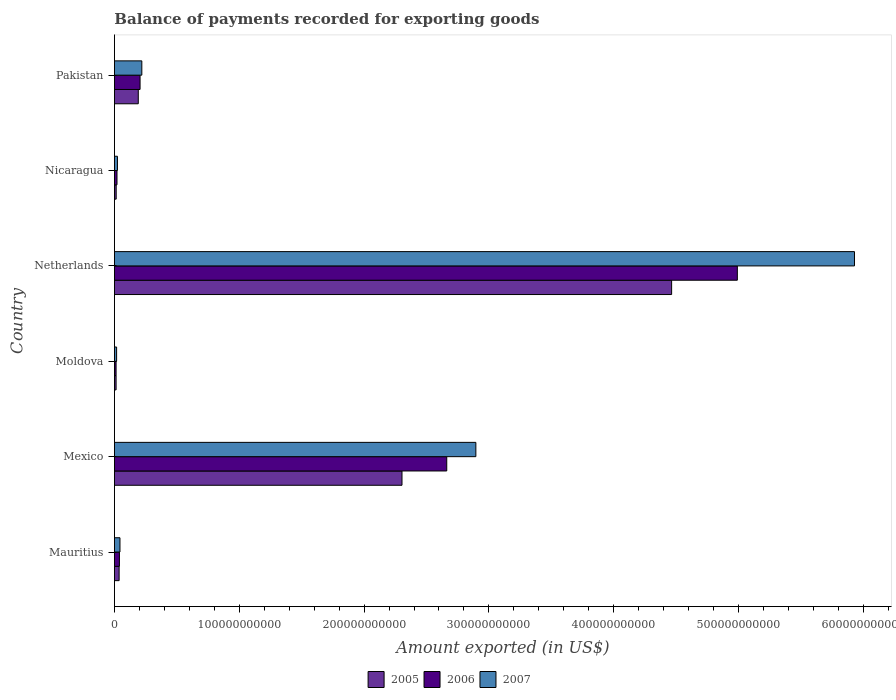How many groups of bars are there?
Your answer should be compact. 6. How many bars are there on the 4th tick from the top?
Make the answer very short. 3. What is the label of the 4th group of bars from the top?
Provide a succinct answer. Moldova. What is the amount exported in 2007 in Mexico?
Provide a succinct answer. 2.90e+11. Across all countries, what is the maximum amount exported in 2005?
Your response must be concise. 4.46e+11. Across all countries, what is the minimum amount exported in 2005?
Keep it short and to the point. 1.33e+09. In which country was the amount exported in 2006 minimum?
Offer a very short reply. Moldova. What is the total amount exported in 2005 in the graph?
Offer a very short reply. 7.02e+11. What is the difference between the amount exported in 2005 in Mexico and that in Nicaragua?
Make the answer very short. 2.29e+11. What is the difference between the amount exported in 2007 in Netherlands and the amount exported in 2005 in Nicaragua?
Provide a short and direct response. 5.91e+11. What is the average amount exported in 2006 per country?
Offer a terse response. 1.32e+11. What is the difference between the amount exported in 2005 and amount exported in 2007 in Mauritius?
Give a very brief answer. -6.87e+08. In how many countries, is the amount exported in 2005 greater than 100000000000 US$?
Offer a very short reply. 2. What is the ratio of the amount exported in 2007 in Mauritius to that in Moldova?
Your answer should be compact. 2.55. What is the difference between the highest and the second highest amount exported in 2007?
Keep it short and to the point. 3.03e+11. What is the difference between the highest and the lowest amount exported in 2007?
Your answer should be very brief. 5.91e+11. In how many countries, is the amount exported in 2006 greater than the average amount exported in 2006 taken over all countries?
Keep it short and to the point. 2. Is the sum of the amount exported in 2006 in Moldova and Pakistan greater than the maximum amount exported in 2005 across all countries?
Your response must be concise. No. Are all the bars in the graph horizontal?
Your answer should be compact. Yes. What is the difference between two consecutive major ticks on the X-axis?
Your response must be concise. 1.00e+11. Does the graph contain grids?
Offer a terse response. No. How many legend labels are there?
Keep it short and to the point. 3. What is the title of the graph?
Give a very brief answer. Balance of payments recorded for exporting goods. What is the label or title of the X-axis?
Offer a very short reply. Amount exported (in US$). What is the label or title of the Y-axis?
Offer a very short reply. Country. What is the Amount exported (in US$) of 2005 in Mauritius?
Make the answer very short. 3.76e+09. What is the Amount exported (in US$) in 2006 in Mauritius?
Provide a short and direct response. 4.00e+09. What is the Amount exported (in US$) of 2007 in Mauritius?
Your response must be concise. 4.44e+09. What is the Amount exported (in US$) of 2005 in Mexico?
Keep it short and to the point. 2.30e+11. What is the Amount exported (in US$) of 2006 in Mexico?
Your answer should be very brief. 2.66e+11. What is the Amount exported (in US$) of 2007 in Mexico?
Give a very brief answer. 2.90e+11. What is the Amount exported (in US$) in 2005 in Moldova?
Ensure brevity in your answer.  1.33e+09. What is the Amount exported (in US$) of 2006 in Moldova?
Offer a very short reply. 1.32e+09. What is the Amount exported (in US$) in 2007 in Moldova?
Your response must be concise. 1.75e+09. What is the Amount exported (in US$) of 2005 in Netherlands?
Ensure brevity in your answer.  4.46e+11. What is the Amount exported (in US$) of 2006 in Netherlands?
Your response must be concise. 4.99e+11. What is the Amount exported (in US$) of 2007 in Netherlands?
Your answer should be compact. 5.93e+11. What is the Amount exported (in US$) in 2005 in Nicaragua?
Ensure brevity in your answer.  1.41e+09. What is the Amount exported (in US$) of 2006 in Nicaragua?
Provide a short and direct response. 2.05e+09. What is the Amount exported (in US$) in 2007 in Nicaragua?
Ensure brevity in your answer.  2.42e+09. What is the Amount exported (in US$) in 2005 in Pakistan?
Give a very brief answer. 1.91e+1. What is the Amount exported (in US$) of 2006 in Pakistan?
Offer a terse response. 2.05e+1. What is the Amount exported (in US$) in 2007 in Pakistan?
Your answer should be very brief. 2.19e+1. Across all countries, what is the maximum Amount exported (in US$) in 2005?
Provide a succinct answer. 4.46e+11. Across all countries, what is the maximum Amount exported (in US$) of 2006?
Give a very brief answer. 4.99e+11. Across all countries, what is the maximum Amount exported (in US$) of 2007?
Provide a short and direct response. 5.93e+11. Across all countries, what is the minimum Amount exported (in US$) of 2005?
Offer a terse response. 1.33e+09. Across all countries, what is the minimum Amount exported (in US$) in 2006?
Provide a short and direct response. 1.32e+09. Across all countries, what is the minimum Amount exported (in US$) of 2007?
Offer a very short reply. 1.75e+09. What is the total Amount exported (in US$) of 2005 in the graph?
Keep it short and to the point. 7.02e+11. What is the total Amount exported (in US$) of 2006 in the graph?
Give a very brief answer. 7.93e+11. What is the total Amount exported (in US$) of 2007 in the graph?
Provide a short and direct response. 9.13e+11. What is the difference between the Amount exported (in US$) in 2005 in Mauritius and that in Mexico?
Your response must be concise. -2.27e+11. What is the difference between the Amount exported (in US$) of 2006 in Mauritius and that in Mexico?
Your response must be concise. -2.62e+11. What is the difference between the Amount exported (in US$) in 2007 in Mauritius and that in Mexico?
Provide a short and direct response. -2.85e+11. What is the difference between the Amount exported (in US$) of 2005 in Mauritius and that in Moldova?
Offer a terse response. 2.42e+09. What is the difference between the Amount exported (in US$) of 2006 in Mauritius and that in Moldova?
Your answer should be compact. 2.68e+09. What is the difference between the Amount exported (in US$) in 2007 in Mauritius and that in Moldova?
Offer a terse response. 2.70e+09. What is the difference between the Amount exported (in US$) in 2005 in Mauritius and that in Netherlands?
Your answer should be very brief. -4.43e+11. What is the difference between the Amount exported (in US$) in 2006 in Mauritius and that in Netherlands?
Offer a very short reply. -4.95e+11. What is the difference between the Amount exported (in US$) of 2007 in Mauritius and that in Netherlands?
Give a very brief answer. -5.88e+11. What is the difference between the Amount exported (in US$) of 2005 in Mauritius and that in Nicaragua?
Offer a very short reply. 2.35e+09. What is the difference between the Amount exported (in US$) of 2006 in Mauritius and that in Nicaragua?
Provide a short and direct response. 1.95e+09. What is the difference between the Amount exported (in US$) in 2007 in Mauritius and that in Nicaragua?
Provide a short and direct response. 2.02e+09. What is the difference between the Amount exported (in US$) of 2005 in Mauritius and that in Pakistan?
Provide a short and direct response. -1.53e+1. What is the difference between the Amount exported (in US$) in 2006 in Mauritius and that in Pakistan?
Your answer should be compact. -1.65e+1. What is the difference between the Amount exported (in US$) in 2007 in Mauritius and that in Pakistan?
Provide a succinct answer. -1.75e+1. What is the difference between the Amount exported (in US$) in 2005 in Mexico and that in Moldova?
Make the answer very short. 2.29e+11. What is the difference between the Amount exported (in US$) in 2006 in Mexico and that in Moldova?
Provide a short and direct response. 2.65e+11. What is the difference between the Amount exported (in US$) of 2007 in Mexico and that in Moldova?
Offer a terse response. 2.88e+11. What is the difference between the Amount exported (in US$) of 2005 in Mexico and that in Netherlands?
Offer a terse response. -2.16e+11. What is the difference between the Amount exported (in US$) in 2006 in Mexico and that in Netherlands?
Give a very brief answer. -2.33e+11. What is the difference between the Amount exported (in US$) in 2007 in Mexico and that in Netherlands?
Give a very brief answer. -3.03e+11. What is the difference between the Amount exported (in US$) in 2005 in Mexico and that in Nicaragua?
Provide a short and direct response. 2.29e+11. What is the difference between the Amount exported (in US$) of 2006 in Mexico and that in Nicaragua?
Ensure brevity in your answer.  2.64e+11. What is the difference between the Amount exported (in US$) in 2007 in Mexico and that in Nicaragua?
Provide a succinct answer. 2.87e+11. What is the difference between the Amount exported (in US$) of 2005 in Mexico and that in Pakistan?
Your answer should be compact. 2.11e+11. What is the difference between the Amount exported (in US$) of 2006 in Mexico and that in Pakistan?
Your answer should be very brief. 2.46e+11. What is the difference between the Amount exported (in US$) of 2007 in Mexico and that in Pakistan?
Your answer should be compact. 2.68e+11. What is the difference between the Amount exported (in US$) of 2005 in Moldova and that in Netherlands?
Provide a short and direct response. -4.45e+11. What is the difference between the Amount exported (in US$) in 2006 in Moldova and that in Netherlands?
Keep it short and to the point. -4.98e+11. What is the difference between the Amount exported (in US$) in 2007 in Moldova and that in Netherlands?
Keep it short and to the point. -5.91e+11. What is the difference between the Amount exported (in US$) in 2005 in Moldova and that in Nicaragua?
Your answer should be very brief. -7.89e+07. What is the difference between the Amount exported (in US$) in 2006 in Moldova and that in Nicaragua?
Offer a terse response. -7.32e+08. What is the difference between the Amount exported (in US$) in 2007 in Moldova and that in Nicaragua?
Provide a succinct answer. -6.74e+08. What is the difference between the Amount exported (in US$) in 2005 in Moldova and that in Pakistan?
Provide a short and direct response. -1.78e+1. What is the difference between the Amount exported (in US$) in 2006 in Moldova and that in Pakistan?
Ensure brevity in your answer.  -1.92e+1. What is the difference between the Amount exported (in US$) in 2007 in Moldova and that in Pakistan?
Provide a short and direct response. -2.02e+1. What is the difference between the Amount exported (in US$) of 2005 in Netherlands and that in Nicaragua?
Your answer should be very brief. 4.45e+11. What is the difference between the Amount exported (in US$) of 2006 in Netherlands and that in Nicaragua?
Provide a succinct answer. 4.97e+11. What is the difference between the Amount exported (in US$) of 2007 in Netherlands and that in Nicaragua?
Offer a very short reply. 5.90e+11. What is the difference between the Amount exported (in US$) of 2005 in Netherlands and that in Pakistan?
Your answer should be very brief. 4.27e+11. What is the difference between the Amount exported (in US$) in 2006 in Netherlands and that in Pakistan?
Your answer should be very brief. 4.78e+11. What is the difference between the Amount exported (in US$) in 2007 in Netherlands and that in Pakistan?
Offer a very short reply. 5.71e+11. What is the difference between the Amount exported (in US$) of 2005 in Nicaragua and that in Pakistan?
Your answer should be compact. -1.77e+1. What is the difference between the Amount exported (in US$) of 2006 in Nicaragua and that in Pakistan?
Make the answer very short. -1.85e+1. What is the difference between the Amount exported (in US$) in 2007 in Nicaragua and that in Pakistan?
Ensure brevity in your answer.  -1.95e+1. What is the difference between the Amount exported (in US$) of 2005 in Mauritius and the Amount exported (in US$) of 2006 in Mexico?
Your answer should be compact. -2.62e+11. What is the difference between the Amount exported (in US$) of 2005 in Mauritius and the Amount exported (in US$) of 2007 in Mexico?
Provide a succinct answer. -2.86e+11. What is the difference between the Amount exported (in US$) of 2006 in Mauritius and the Amount exported (in US$) of 2007 in Mexico?
Make the answer very short. -2.86e+11. What is the difference between the Amount exported (in US$) in 2005 in Mauritius and the Amount exported (in US$) in 2006 in Moldova?
Offer a terse response. 2.43e+09. What is the difference between the Amount exported (in US$) of 2005 in Mauritius and the Amount exported (in US$) of 2007 in Moldova?
Keep it short and to the point. 2.01e+09. What is the difference between the Amount exported (in US$) in 2006 in Mauritius and the Amount exported (in US$) in 2007 in Moldova?
Offer a terse response. 2.25e+09. What is the difference between the Amount exported (in US$) of 2005 in Mauritius and the Amount exported (in US$) of 2006 in Netherlands?
Provide a short and direct response. -4.95e+11. What is the difference between the Amount exported (in US$) in 2005 in Mauritius and the Amount exported (in US$) in 2007 in Netherlands?
Keep it short and to the point. -5.89e+11. What is the difference between the Amount exported (in US$) in 2006 in Mauritius and the Amount exported (in US$) in 2007 in Netherlands?
Ensure brevity in your answer.  -5.89e+11. What is the difference between the Amount exported (in US$) in 2005 in Mauritius and the Amount exported (in US$) in 2006 in Nicaragua?
Ensure brevity in your answer.  1.70e+09. What is the difference between the Amount exported (in US$) of 2005 in Mauritius and the Amount exported (in US$) of 2007 in Nicaragua?
Give a very brief answer. 1.34e+09. What is the difference between the Amount exported (in US$) of 2006 in Mauritius and the Amount exported (in US$) of 2007 in Nicaragua?
Keep it short and to the point. 1.58e+09. What is the difference between the Amount exported (in US$) in 2005 in Mauritius and the Amount exported (in US$) in 2006 in Pakistan?
Your answer should be compact. -1.68e+1. What is the difference between the Amount exported (in US$) in 2005 in Mauritius and the Amount exported (in US$) in 2007 in Pakistan?
Your answer should be very brief. -1.82e+1. What is the difference between the Amount exported (in US$) in 2006 in Mauritius and the Amount exported (in US$) in 2007 in Pakistan?
Your answer should be very brief. -1.79e+1. What is the difference between the Amount exported (in US$) in 2005 in Mexico and the Amount exported (in US$) in 2006 in Moldova?
Your response must be concise. 2.29e+11. What is the difference between the Amount exported (in US$) in 2005 in Mexico and the Amount exported (in US$) in 2007 in Moldova?
Provide a succinct answer. 2.29e+11. What is the difference between the Amount exported (in US$) of 2006 in Mexico and the Amount exported (in US$) of 2007 in Moldova?
Your answer should be compact. 2.64e+11. What is the difference between the Amount exported (in US$) of 2005 in Mexico and the Amount exported (in US$) of 2006 in Netherlands?
Provide a succinct answer. -2.69e+11. What is the difference between the Amount exported (in US$) of 2005 in Mexico and the Amount exported (in US$) of 2007 in Netherlands?
Provide a short and direct response. -3.62e+11. What is the difference between the Amount exported (in US$) in 2006 in Mexico and the Amount exported (in US$) in 2007 in Netherlands?
Your answer should be compact. -3.27e+11. What is the difference between the Amount exported (in US$) in 2005 in Mexico and the Amount exported (in US$) in 2006 in Nicaragua?
Ensure brevity in your answer.  2.28e+11. What is the difference between the Amount exported (in US$) in 2005 in Mexico and the Amount exported (in US$) in 2007 in Nicaragua?
Offer a very short reply. 2.28e+11. What is the difference between the Amount exported (in US$) in 2006 in Mexico and the Amount exported (in US$) in 2007 in Nicaragua?
Keep it short and to the point. 2.64e+11. What is the difference between the Amount exported (in US$) of 2005 in Mexico and the Amount exported (in US$) of 2006 in Pakistan?
Provide a succinct answer. 2.10e+11. What is the difference between the Amount exported (in US$) in 2005 in Mexico and the Amount exported (in US$) in 2007 in Pakistan?
Give a very brief answer. 2.08e+11. What is the difference between the Amount exported (in US$) in 2006 in Mexico and the Amount exported (in US$) in 2007 in Pakistan?
Offer a very short reply. 2.44e+11. What is the difference between the Amount exported (in US$) of 2005 in Moldova and the Amount exported (in US$) of 2006 in Netherlands?
Offer a terse response. -4.98e+11. What is the difference between the Amount exported (in US$) in 2005 in Moldova and the Amount exported (in US$) in 2007 in Netherlands?
Provide a succinct answer. -5.92e+11. What is the difference between the Amount exported (in US$) in 2006 in Moldova and the Amount exported (in US$) in 2007 in Netherlands?
Give a very brief answer. -5.92e+11. What is the difference between the Amount exported (in US$) of 2005 in Moldova and the Amount exported (in US$) of 2006 in Nicaragua?
Your response must be concise. -7.22e+08. What is the difference between the Amount exported (in US$) in 2005 in Moldova and the Amount exported (in US$) in 2007 in Nicaragua?
Offer a very short reply. -1.09e+09. What is the difference between the Amount exported (in US$) in 2006 in Moldova and the Amount exported (in US$) in 2007 in Nicaragua?
Ensure brevity in your answer.  -1.10e+09. What is the difference between the Amount exported (in US$) of 2005 in Moldova and the Amount exported (in US$) of 2006 in Pakistan?
Your answer should be very brief. -1.92e+1. What is the difference between the Amount exported (in US$) of 2005 in Moldova and the Amount exported (in US$) of 2007 in Pakistan?
Provide a short and direct response. -2.06e+1. What is the difference between the Amount exported (in US$) in 2006 in Moldova and the Amount exported (in US$) in 2007 in Pakistan?
Provide a succinct answer. -2.06e+1. What is the difference between the Amount exported (in US$) of 2005 in Netherlands and the Amount exported (in US$) of 2006 in Nicaragua?
Make the answer very short. 4.44e+11. What is the difference between the Amount exported (in US$) of 2005 in Netherlands and the Amount exported (in US$) of 2007 in Nicaragua?
Keep it short and to the point. 4.44e+11. What is the difference between the Amount exported (in US$) in 2006 in Netherlands and the Amount exported (in US$) in 2007 in Nicaragua?
Your answer should be very brief. 4.97e+11. What is the difference between the Amount exported (in US$) in 2005 in Netherlands and the Amount exported (in US$) in 2006 in Pakistan?
Make the answer very short. 4.26e+11. What is the difference between the Amount exported (in US$) of 2005 in Netherlands and the Amount exported (in US$) of 2007 in Pakistan?
Your answer should be compact. 4.24e+11. What is the difference between the Amount exported (in US$) of 2006 in Netherlands and the Amount exported (in US$) of 2007 in Pakistan?
Ensure brevity in your answer.  4.77e+11. What is the difference between the Amount exported (in US$) of 2005 in Nicaragua and the Amount exported (in US$) of 2006 in Pakistan?
Your response must be concise. -1.91e+1. What is the difference between the Amount exported (in US$) of 2005 in Nicaragua and the Amount exported (in US$) of 2007 in Pakistan?
Your answer should be compact. -2.05e+1. What is the difference between the Amount exported (in US$) of 2006 in Nicaragua and the Amount exported (in US$) of 2007 in Pakistan?
Your answer should be compact. -1.99e+1. What is the average Amount exported (in US$) of 2005 per country?
Keep it short and to the point. 1.17e+11. What is the average Amount exported (in US$) of 2006 per country?
Give a very brief answer. 1.32e+11. What is the average Amount exported (in US$) in 2007 per country?
Ensure brevity in your answer.  1.52e+11. What is the difference between the Amount exported (in US$) in 2005 and Amount exported (in US$) in 2006 in Mauritius?
Make the answer very short. -2.44e+08. What is the difference between the Amount exported (in US$) of 2005 and Amount exported (in US$) of 2007 in Mauritius?
Make the answer very short. -6.87e+08. What is the difference between the Amount exported (in US$) in 2006 and Amount exported (in US$) in 2007 in Mauritius?
Give a very brief answer. -4.43e+08. What is the difference between the Amount exported (in US$) in 2005 and Amount exported (in US$) in 2006 in Mexico?
Ensure brevity in your answer.  -3.59e+1. What is the difference between the Amount exported (in US$) of 2005 and Amount exported (in US$) of 2007 in Mexico?
Provide a short and direct response. -5.92e+1. What is the difference between the Amount exported (in US$) in 2006 and Amount exported (in US$) in 2007 in Mexico?
Make the answer very short. -2.33e+1. What is the difference between the Amount exported (in US$) in 2005 and Amount exported (in US$) in 2006 in Moldova?
Ensure brevity in your answer.  1.02e+07. What is the difference between the Amount exported (in US$) in 2005 and Amount exported (in US$) in 2007 in Moldova?
Your response must be concise. -4.13e+08. What is the difference between the Amount exported (in US$) in 2006 and Amount exported (in US$) in 2007 in Moldova?
Offer a terse response. -4.23e+08. What is the difference between the Amount exported (in US$) of 2005 and Amount exported (in US$) of 2006 in Netherlands?
Your answer should be compact. -5.27e+1. What is the difference between the Amount exported (in US$) of 2005 and Amount exported (in US$) of 2007 in Netherlands?
Give a very brief answer. -1.46e+11. What is the difference between the Amount exported (in US$) of 2006 and Amount exported (in US$) of 2007 in Netherlands?
Ensure brevity in your answer.  -9.38e+1. What is the difference between the Amount exported (in US$) in 2005 and Amount exported (in US$) in 2006 in Nicaragua?
Your answer should be compact. -6.43e+08. What is the difference between the Amount exported (in US$) of 2005 and Amount exported (in US$) of 2007 in Nicaragua?
Your response must be concise. -1.01e+09. What is the difference between the Amount exported (in US$) in 2006 and Amount exported (in US$) in 2007 in Nicaragua?
Offer a very short reply. -3.66e+08. What is the difference between the Amount exported (in US$) of 2005 and Amount exported (in US$) of 2006 in Pakistan?
Provide a short and direct response. -1.44e+09. What is the difference between the Amount exported (in US$) of 2005 and Amount exported (in US$) of 2007 in Pakistan?
Ensure brevity in your answer.  -2.84e+09. What is the difference between the Amount exported (in US$) of 2006 and Amount exported (in US$) of 2007 in Pakistan?
Ensure brevity in your answer.  -1.41e+09. What is the ratio of the Amount exported (in US$) of 2005 in Mauritius to that in Mexico?
Give a very brief answer. 0.02. What is the ratio of the Amount exported (in US$) of 2006 in Mauritius to that in Mexico?
Ensure brevity in your answer.  0.01. What is the ratio of the Amount exported (in US$) in 2007 in Mauritius to that in Mexico?
Offer a very short reply. 0.02. What is the ratio of the Amount exported (in US$) in 2005 in Mauritius to that in Moldova?
Keep it short and to the point. 2.82. What is the ratio of the Amount exported (in US$) of 2006 in Mauritius to that in Moldova?
Your answer should be very brief. 3.03. What is the ratio of the Amount exported (in US$) of 2007 in Mauritius to that in Moldova?
Ensure brevity in your answer.  2.55. What is the ratio of the Amount exported (in US$) of 2005 in Mauritius to that in Netherlands?
Your response must be concise. 0.01. What is the ratio of the Amount exported (in US$) of 2006 in Mauritius to that in Netherlands?
Give a very brief answer. 0.01. What is the ratio of the Amount exported (in US$) in 2007 in Mauritius to that in Netherlands?
Your answer should be very brief. 0.01. What is the ratio of the Amount exported (in US$) in 2005 in Mauritius to that in Nicaragua?
Make the answer very short. 2.66. What is the ratio of the Amount exported (in US$) in 2006 in Mauritius to that in Nicaragua?
Offer a very short reply. 1.95. What is the ratio of the Amount exported (in US$) of 2007 in Mauritius to that in Nicaragua?
Offer a very short reply. 1.84. What is the ratio of the Amount exported (in US$) of 2005 in Mauritius to that in Pakistan?
Ensure brevity in your answer.  0.2. What is the ratio of the Amount exported (in US$) in 2006 in Mauritius to that in Pakistan?
Your response must be concise. 0.19. What is the ratio of the Amount exported (in US$) in 2007 in Mauritius to that in Pakistan?
Your answer should be compact. 0.2. What is the ratio of the Amount exported (in US$) in 2005 in Mexico to that in Moldova?
Your answer should be compact. 172.92. What is the ratio of the Amount exported (in US$) of 2006 in Mexico to that in Moldova?
Give a very brief answer. 201.37. What is the ratio of the Amount exported (in US$) of 2007 in Mexico to that in Moldova?
Provide a short and direct response. 165.88. What is the ratio of the Amount exported (in US$) of 2005 in Mexico to that in Netherlands?
Ensure brevity in your answer.  0.52. What is the ratio of the Amount exported (in US$) in 2006 in Mexico to that in Netherlands?
Give a very brief answer. 0.53. What is the ratio of the Amount exported (in US$) of 2007 in Mexico to that in Netherlands?
Your response must be concise. 0.49. What is the ratio of the Amount exported (in US$) of 2005 in Mexico to that in Nicaragua?
Your answer should be compact. 163.25. What is the ratio of the Amount exported (in US$) of 2006 in Mexico to that in Nicaragua?
Provide a succinct answer. 129.61. What is the ratio of the Amount exported (in US$) in 2007 in Mexico to that in Nicaragua?
Offer a very short reply. 119.67. What is the ratio of the Amount exported (in US$) in 2005 in Mexico to that in Pakistan?
Your answer should be very brief. 12.06. What is the ratio of the Amount exported (in US$) in 2006 in Mexico to that in Pakistan?
Your response must be concise. 12.96. What is the ratio of the Amount exported (in US$) in 2007 in Mexico to that in Pakistan?
Your answer should be compact. 13.19. What is the ratio of the Amount exported (in US$) in 2005 in Moldova to that in Netherlands?
Make the answer very short. 0. What is the ratio of the Amount exported (in US$) of 2006 in Moldova to that in Netherlands?
Keep it short and to the point. 0. What is the ratio of the Amount exported (in US$) of 2007 in Moldova to that in Netherlands?
Your answer should be very brief. 0. What is the ratio of the Amount exported (in US$) in 2005 in Moldova to that in Nicaragua?
Your answer should be compact. 0.94. What is the ratio of the Amount exported (in US$) in 2006 in Moldova to that in Nicaragua?
Keep it short and to the point. 0.64. What is the ratio of the Amount exported (in US$) in 2007 in Moldova to that in Nicaragua?
Your answer should be compact. 0.72. What is the ratio of the Amount exported (in US$) in 2005 in Moldova to that in Pakistan?
Your response must be concise. 0.07. What is the ratio of the Amount exported (in US$) of 2006 in Moldova to that in Pakistan?
Keep it short and to the point. 0.06. What is the ratio of the Amount exported (in US$) of 2007 in Moldova to that in Pakistan?
Your answer should be compact. 0.08. What is the ratio of the Amount exported (in US$) in 2005 in Netherlands to that in Nicaragua?
Provide a short and direct response. 316.32. What is the ratio of the Amount exported (in US$) in 2006 in Netherlands to that in Nicaragua?
Offer a very short reply. 242.95. What is the ratio of the Amount exported (in US$) of 2007 in Netherlands to that in Nicaragua?
Your response must be concise. 245.03. What is the ratio of the Amount exported (in US$) of 2005 in Netherlands to that in Pakistan?
Ensure brevity in your answer.  23.37. What is the ratio of the Amount exported (in US$) of 2006 in Netherlands to that in Pakistan?
Offer a terse response. 24.3. What is the ratio of the Amount exported (in US$) in 2007 in Netherlands to that in Pakistan?
Ensure brevity in your answer.  27.02. What is the ratio of the Amount exported (in US$) in 2005 in Nicaragua to that in Pakistan?
Make the answer very short. 0.07. What is the ratio of the Amount exported (in US$) in 2006 in Nicaragua to that in Pakistan?
Your answer should be very brief. 0.1. What is the ratio of the Amount exported (in US$) of 2007 in Nicaragua to that in Pakistan?
Ensure brevity in your answer.  0.11. What is the difference between the highest and the second highest Amount exported (in US$) of 2005?
Offer a terse response. 2.16e+11. What is the difference between the highest and the second highest Amount exported (in US$) of 2006?
Your answer should be compact. 2.33e+11. What is the difference between the highest and the second highest Amount exported (in US$) in 2007?
Your response must be concise. 3.03e+11. What is the difference between the highest and the lowest Amount exported (in US$) of 2005?
Provide a short and direct response. 4.45e+11. What is the difference between the highest and the lowest Amount exported (in US$) in 2006?
Keep it short and to the point. 4.98e+11. What is the difference between the highest and the lowest Amount exported (in US$) of 2007?
Ensure brevity in your answer.  5.91e+11. 